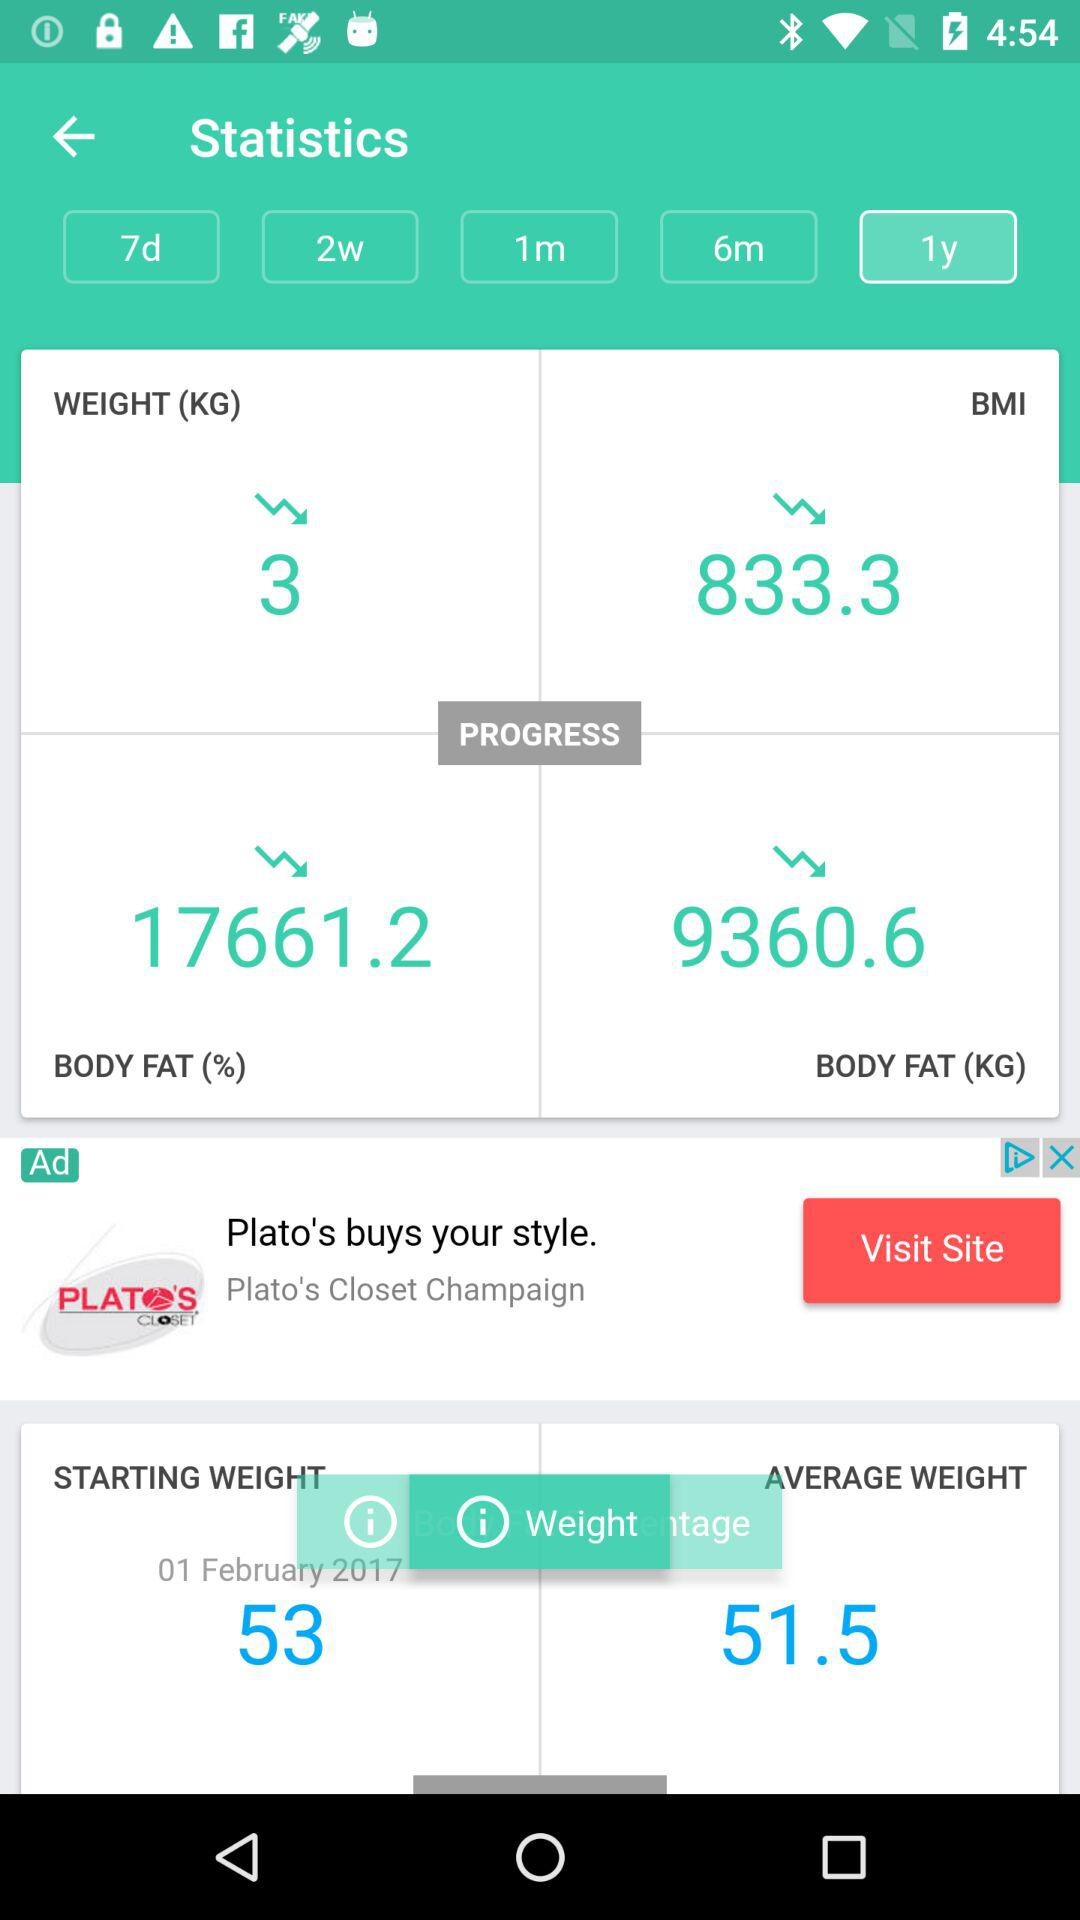How much has BMI decreased? BMI has decreased to 833.3. 